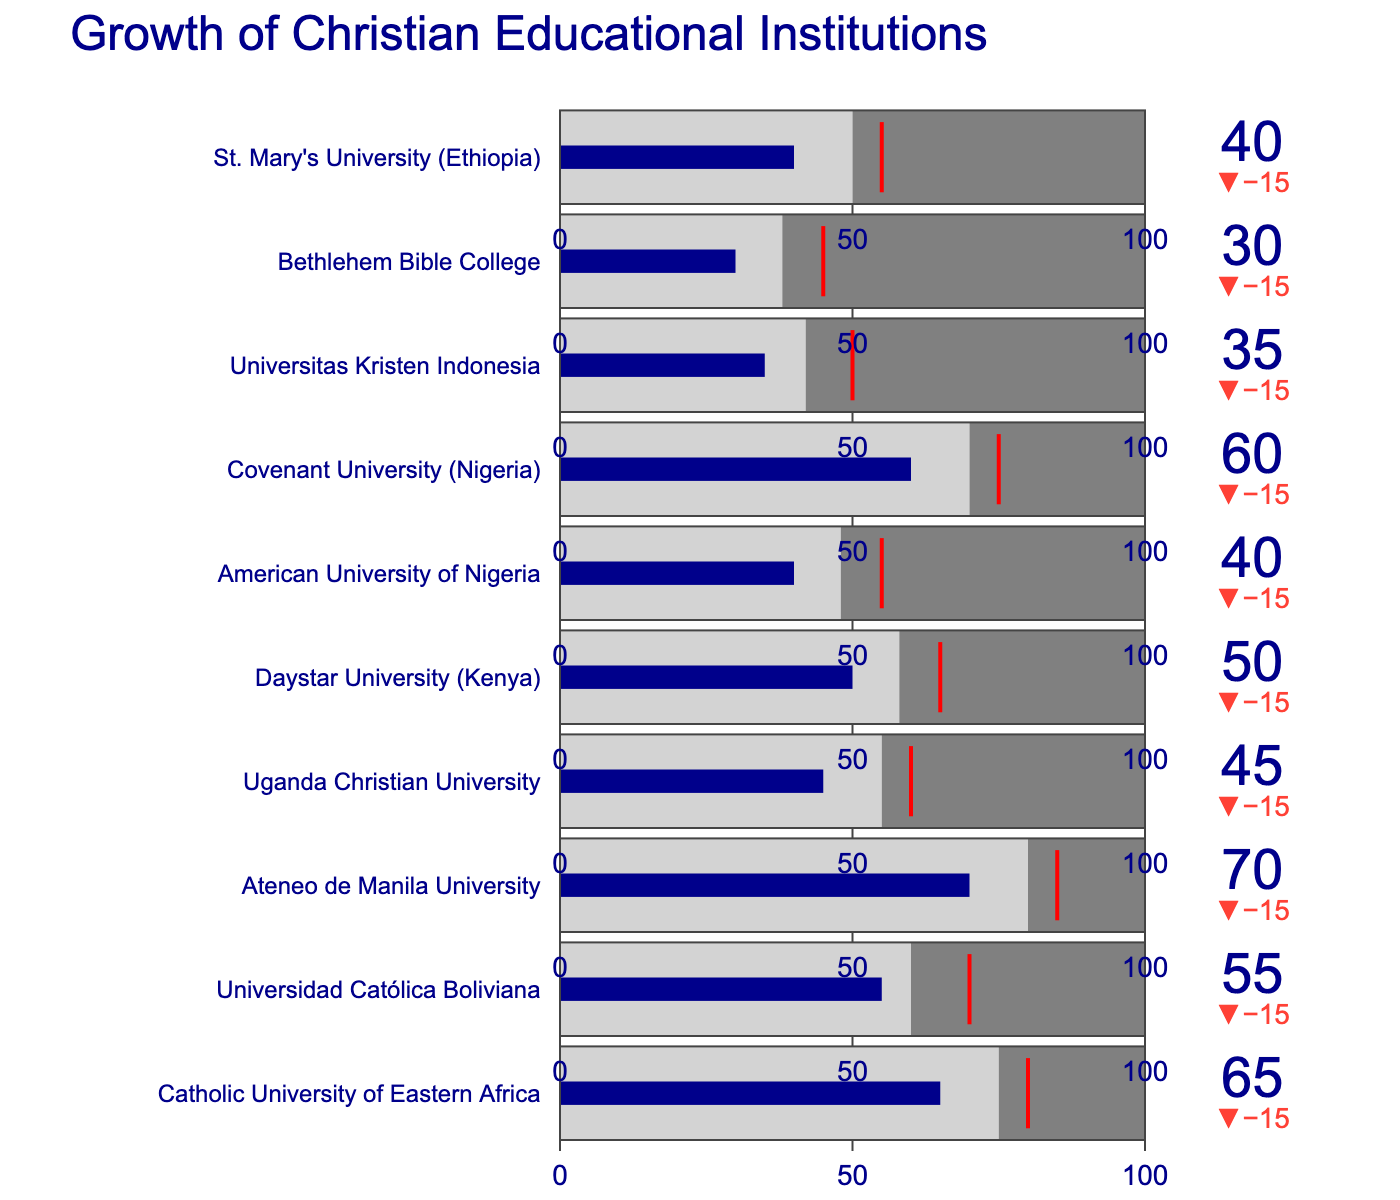Which institution has the highest actual growth? To find the institution with the highest actual growth, scan through the "Actual Growth" values for each institution and identify the highest number.
Answer: Ateneo de Manila University What is the difference between the target growth and actual growth for the Catholic University of Eastern Africa? Subtract the actual growth value (65) from the target growth value (80) for the Catholic University of Eastern Africa.
Answer: 15 Which institution has a comparative growth of 42? Look through the "Comparative Growth" values to find the institution with a value of 42.
Answer: Universitas Kristen Indonesia How many institutions exceed their comparative growth in actual growth? Compare the "Actual Growth" figures against the "Comparative Growth" figures for each institution and count how many actual growth values are greater.
Answer: 10 Which institution falls the shortest from its target growth? Calculate the difference between the target growth and actual growth for each institution and identify which has the smallest difference.
Answer: Ateneo de Manila University What is the average actual growth of all the institutions? Sum all the "Actual Growth" values and divide by the number of institutions (10). (65 + 55 + 70 + 45 + 50 + 40 + 60 + 35 + 30 + 40) / 10
Answer: 49 Which institution shows the smallest comparative growth between secular and Christian educational institutions? Identify the institution with the smallest "Comparative Growth" value.
Answer: Bethlehem Bible College 